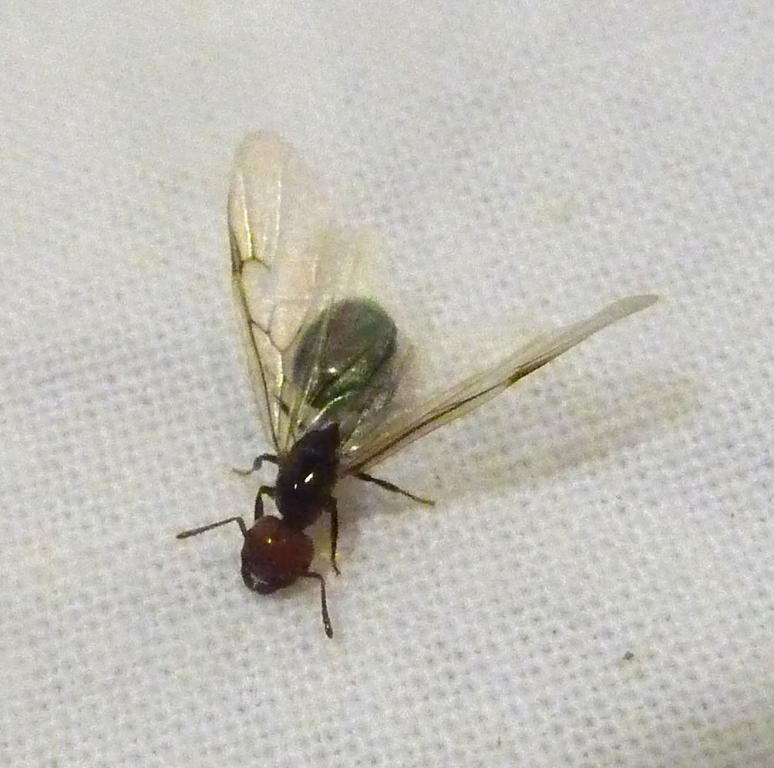What type of creature is in the image? There is an insect in the image. What color is the insect? The insect is brown in color. What is the background or surface the insect is on? The insect is on a white surface. What type of knee injury can be seen in the image? There is no knee injury present in the image; it features an insect on a white surface. 